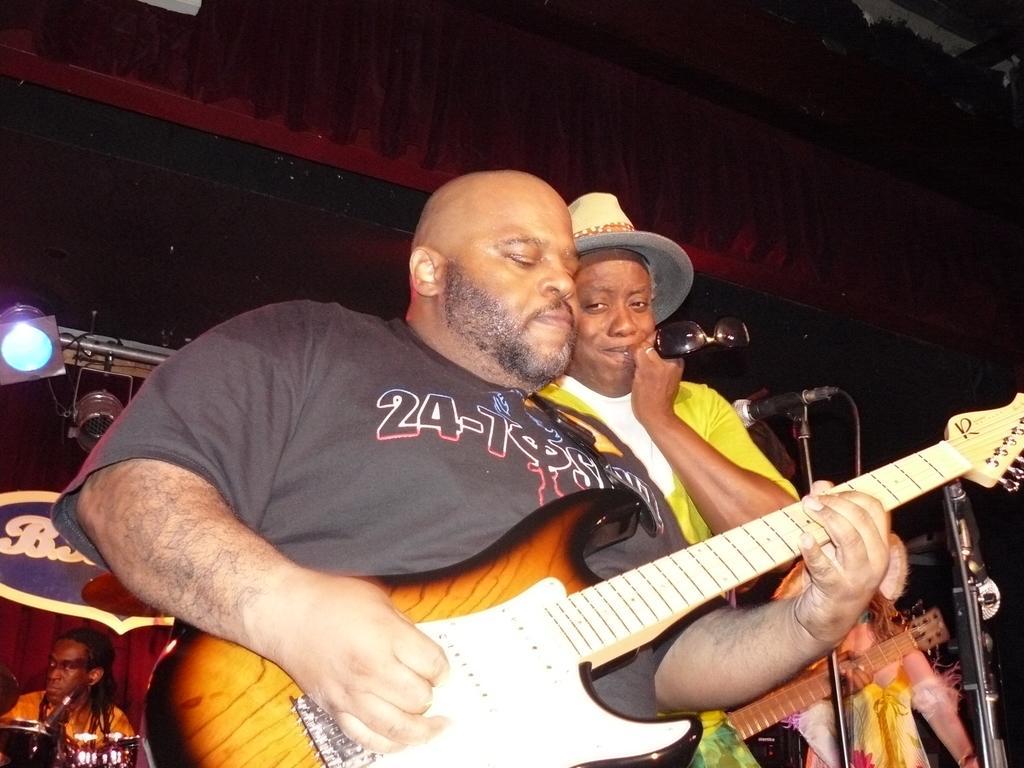In one or two sentences, can you explain what this image depicts? In this image, few peoples are playing a musical instrument. And the person in the middle, he hold a goggles. At the background, we can see banners, curtain and light. 